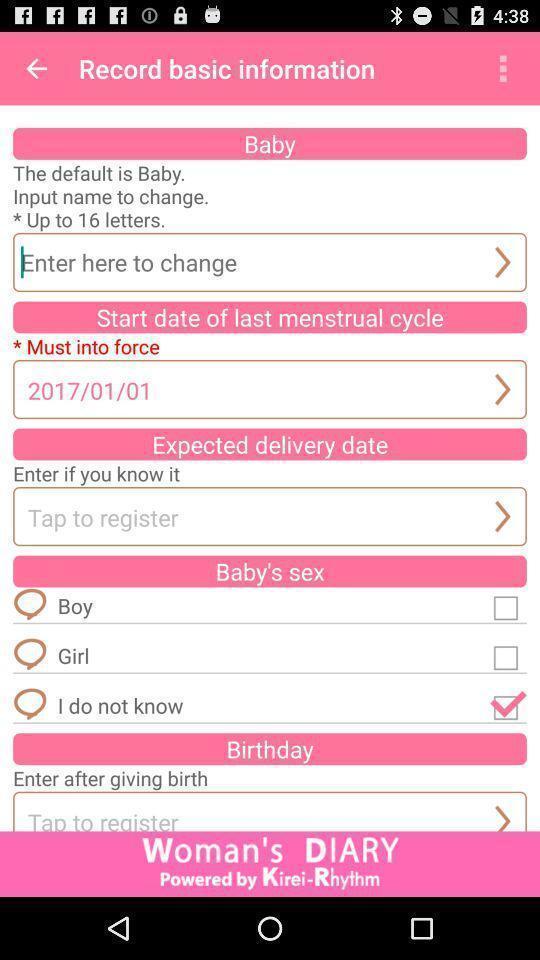Describe the visual elements of this screenshot. Record basic information about baby. 